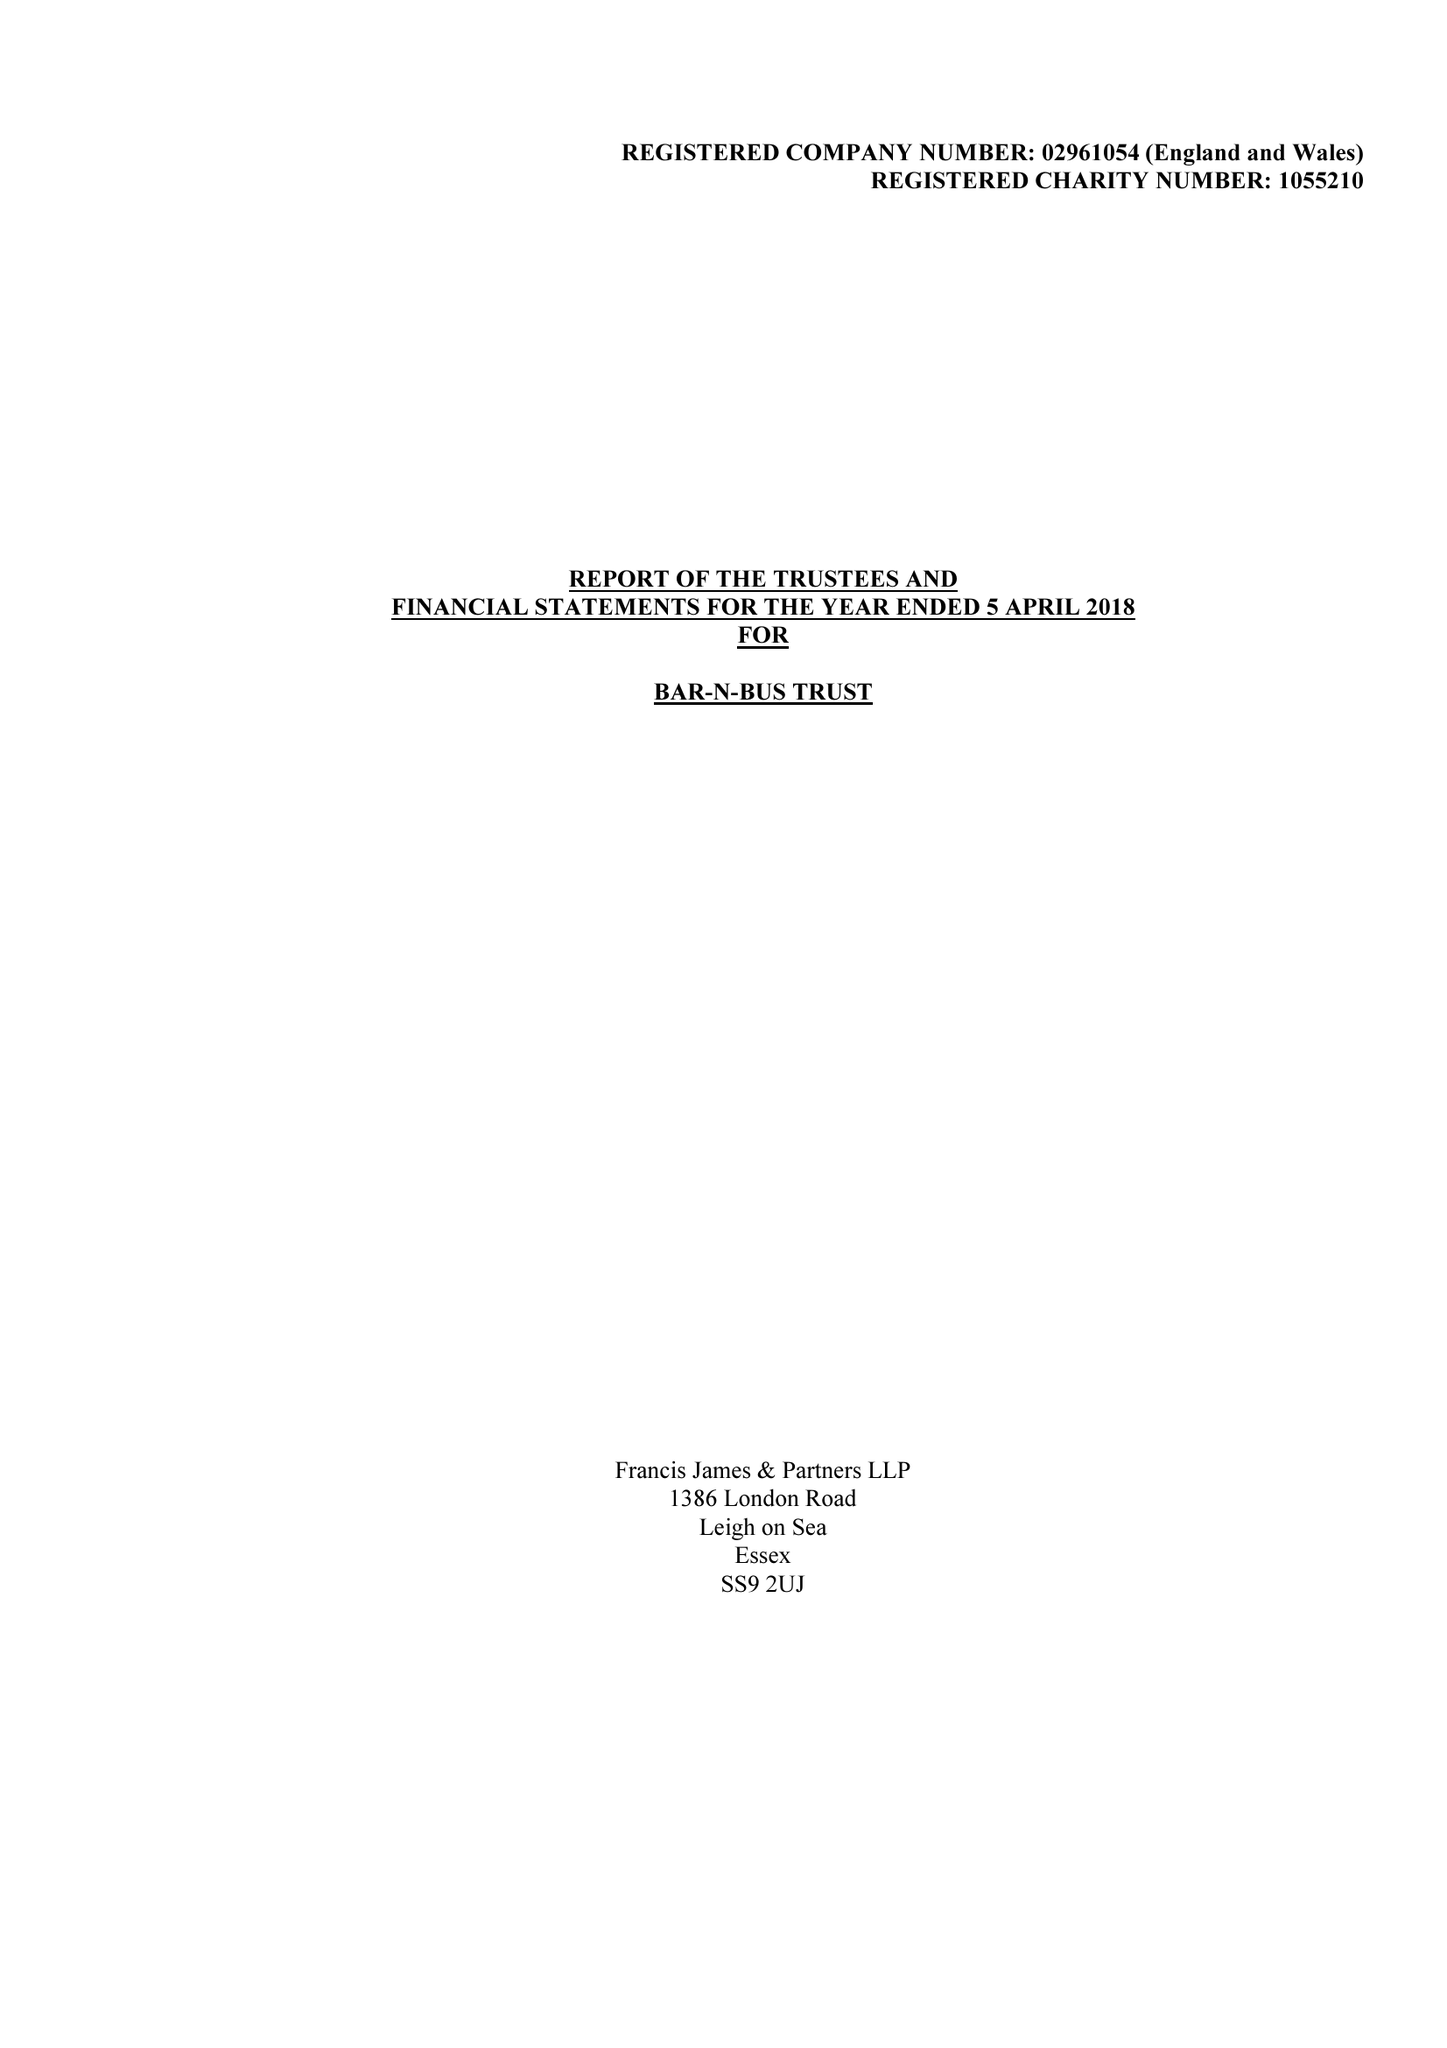What is the value for the spending_annually_in_british_pounds?
Answer the question using a single word or phrase. 29488.00 